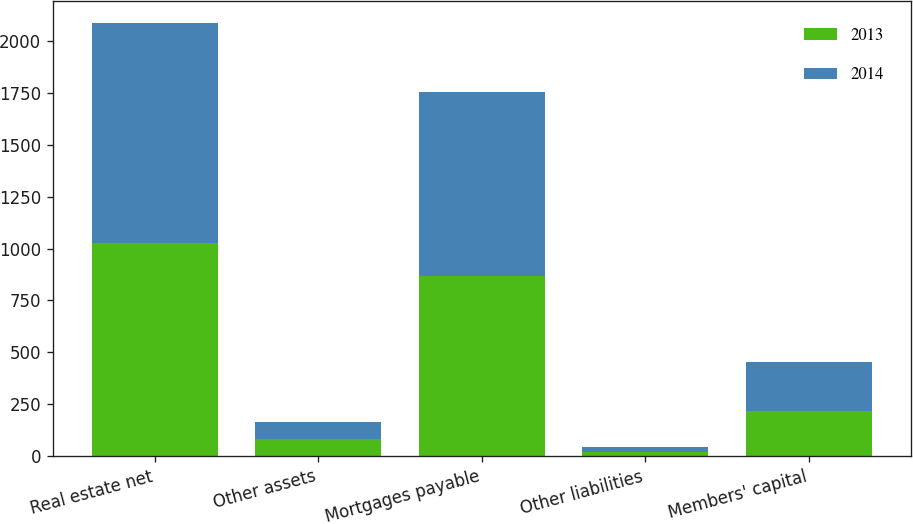<chart> <loc_0><loc_0><loc_500><loc_500><stacked_bar_chart><ecel><fcel>Real estate net<fcel>Other assets<fcel>Mortgages payable<fcel>Other liabilities<fcel>Members' capital<nl><fcel>2013<fcel>1024.3<fcel>80.5<fcel>866.4<fcel>19.8<fcel>218.6<nl><fcel>2014<fcel>1064.2<fcel>81.9<fcel>889.1<fcel>21.8<fcel>235.2<nl></chart> 